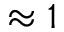<formula> <loc_0><loc_0><loc_500><loc_500>\approx 1</formula> 